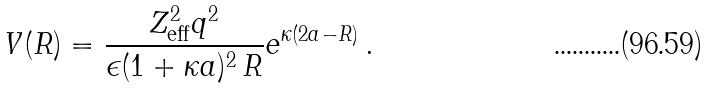<formula> <loc_0><loc_0><loc_500><loc_500>V ( R ) = \frac { Z _ { \text {eff} } ^ { 2 } q ^ { 2 } } { \epsilon ( 1 + \kappa a ) ^ { 2 } \, R } e ^ { \kappa ( 2 a - R ) } \, .</formula> 